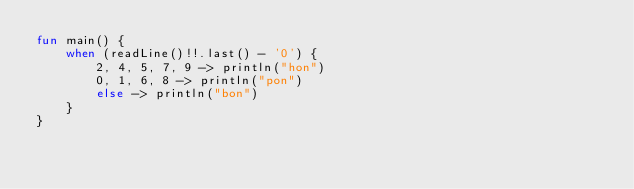<code> <loc_0><loc_0><loc_500><loc_500><_Kotlin_>fun main() {
    when (readLine()!!.last() - '0') {
        2, 4, 5, 7, 9 -> println("hon")
        0, 1, 6, 8 -> println("pon")
        else -> println("bon")
    }
}</code> 